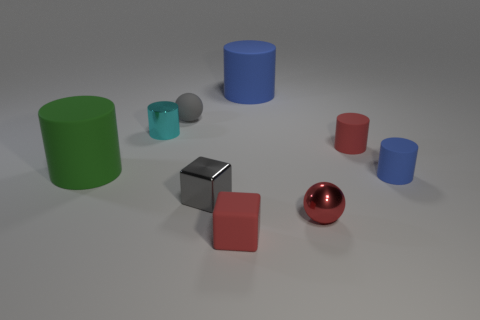Do the large cylinder on the right side of the gray rubber thing and the green object have the same material?
Give a very brief answer. Yes. There is a tiny gray thing in front of the tiny gray matte thing; are there any matte things left of it?
Offer a very short reply. Yes. There is a big green thing that is the same shape as the cyan thing; what is it made of?
Provide a succinct answer. Rubber. Is the number of metallic things in front of the green cylinder greater than the number of small gray cubes behind the matte ball?
Offer a very short reply. Yes. There is a red object that is made of the same material as the gray cube; what is its shape?
Offer a very short reply. Sphere. Is the number of big rubber objects to the right of the green matte thing greater than the number of big objects?
Give a very brief answer. No. What number of rubber balls are the same color as the tiny shiny ball?
Provide a succinct answer. 0. What number of other objects are there of the same color as the small metal cylinder?
Provide a succinct answer. 0. Are there more red rubber things than large blue objects?
Provide a succinct answer. Yes. What is the green object made of?
Ensure brevity in your answer.  Rubber. 